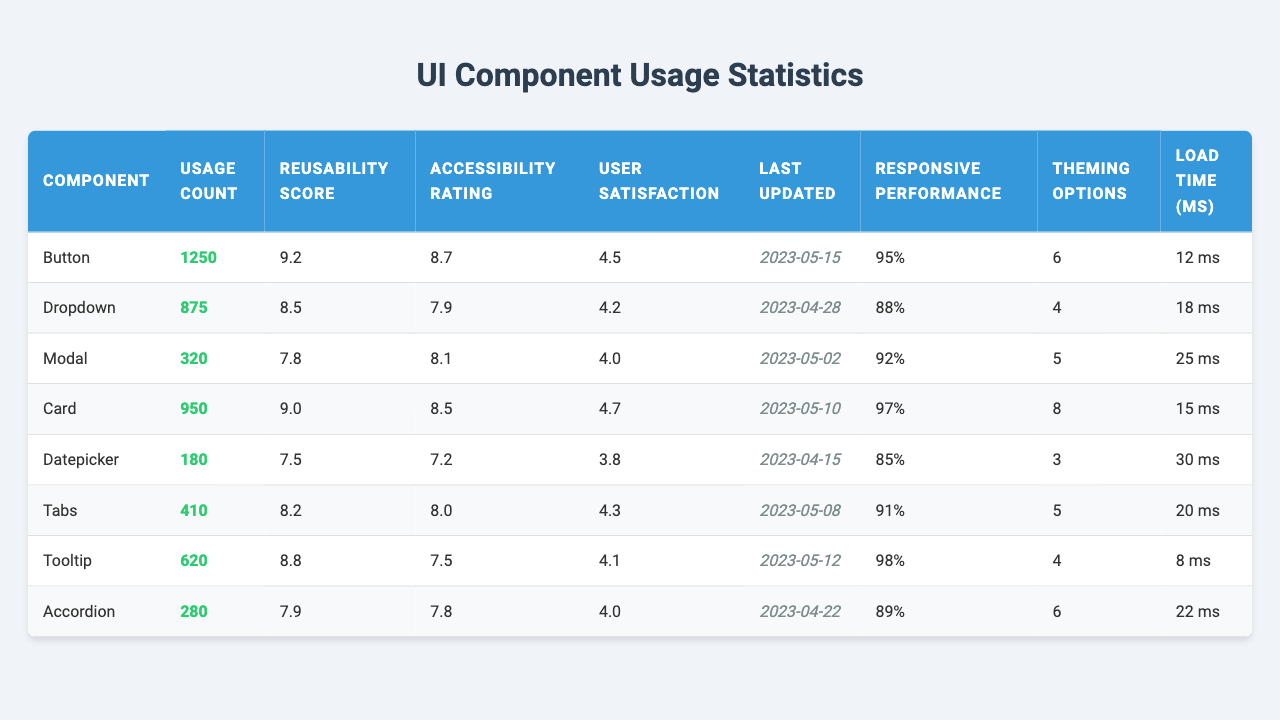What is the usage count of the "Button" component? The table shows that the usage count for the "Button" component is listed directly under the "Usage Count" column. It displays a value of 1250.
Answer: 1250 Which component has the highest user satisfaction rating? By reviewing the "User Satisfaction" column, we can see that the "Card" component has the highest rating of 4.7, compared to the other components.
Answer: Card What is the average reusability score of all components? To find the average, we add all the reusability scores: 9.2 + 8.5 + 7.8 + 9.0 + 7.5 + 8.2 + 8.8 + 7.9 = 67.9. There are 8 components, so the average is 67.9 / 8 = 8.4875, which rounds to 8.5.
Answer: 8.5 Which component was last updated most recently? The "Last Updated" column lists the dates, and by checking the most recent date, we see "Button" was last updated on 2023-05-15, which is the latest among all components.
Answer: Button Is the accessibility rating of the "Dropdown" component higher than 8? The "Dropdown" component's accessibility rating is listed as 7.9, which is less than 8, confirming the statement is false.
Answer: No What is the total load time of all components combined? Summing all load times: 12 + 18 + 25 + 15 + 30 + 20 + 8 + 22 = 150 ms. Thus, the total load time for all components is 150 ms.
Answer: 150 ms Which component has the lowest responsiveness performance rating? By reviewing the "Responsive Performance" column, we find the "Datepicker" has the lowest performance rating at 85%, while others score higher.
Answer: Datepicker How many theming options does the "Tooltip" component have compared to the "Modal" component? The "Tooltip" component has 4 theming options and the "Modal" has 5. Thus, the "Modal" component has 1 more theming option than the "Tooltip" component.
Answer: 1 more Is the user satisfaction rating of the "Accordion" component less than that of the "Tooltip"? The "Accordion" has a user satisfaction rating of 4.0, while the "Tooltip" has 4.1. Since 4.0 is less than 4.1, the statement is true.
Answer: Yes What is the difference in usage count between the "Card" and "Modal" components? The "Card" component has a usage count of 950 while the "Modal" has 320. The difference is calculated as 950 - 320 = 630.
Answer: 630 